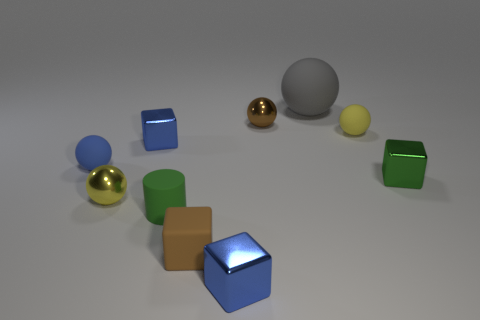Subtract all blue cubes. How many were subtracted if there are1blue cubes left? 1 Subtract all cylinders. How many objects are left? 9 Subtract all brown balls. How many balls are left? 4 Add 3 tiny cyan metal cylinders. How many tiny cyan metal cylinders exist? 3 Subtract all gray spheres. How many spheres are left? 4 Subtract 0 blue cylinders. How many objects are left? 10 Subtract 5 spheres. How many spheres are left? 0 Subtract all yellow cubes. Subtract all red cylinders. How many cubes are left? 4 Subtract all purple spheres. How many blue cubes are left? 2 Subtract all tiny brown blocks. Subtract all brown blocks. How many objects are left? 8 